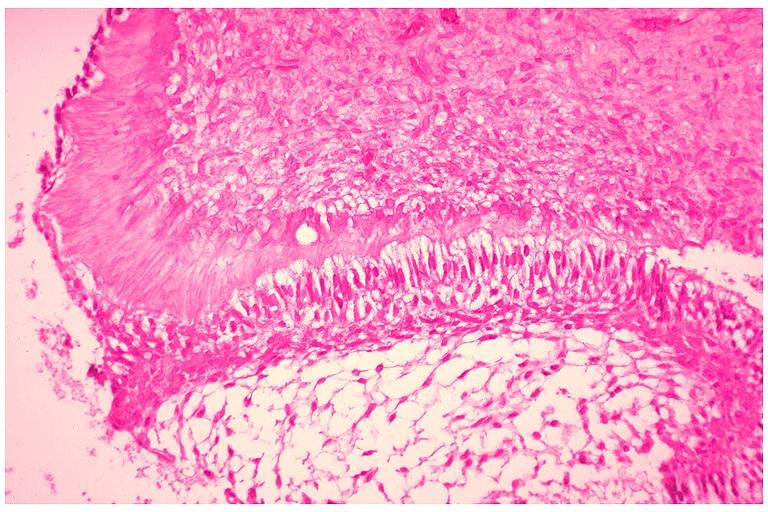does mixed mesodermal tumor show developing 3rd molar?
Answer the question using a single word or phrase. No 